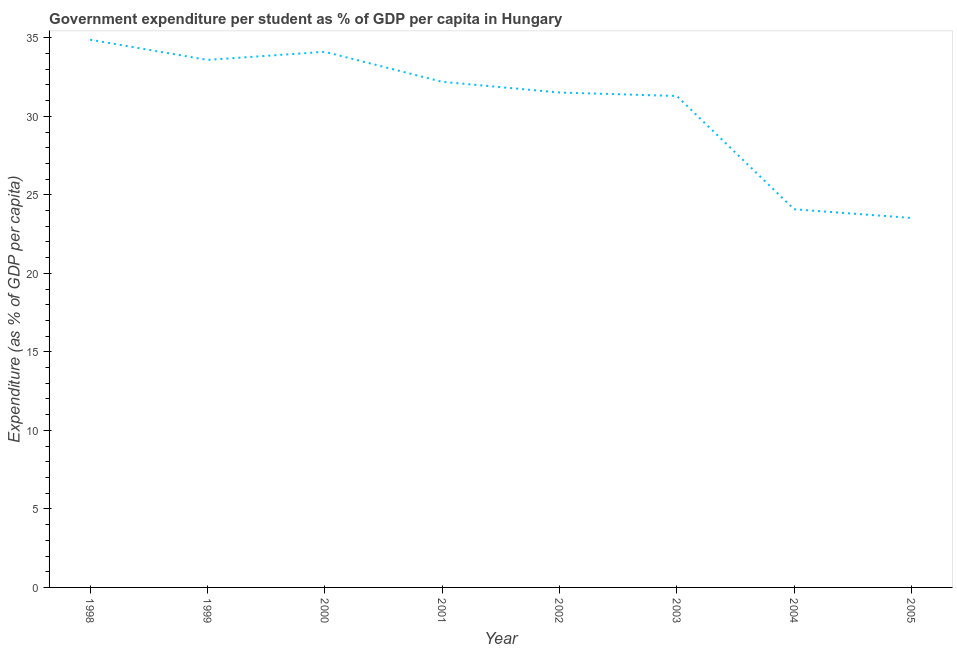What is the government expenditure per student in 1999?
Make the answer very short. 33.59. Across all years, what is the maximum government expenditure per student?
Give a very brief answer. 34.88. Across all years, what is the minimum government expenditure per student?
Ensure brevity in your answer.  23.53. In which year was the government expenditure per student minimum?
Provide a succinct answer. 2005. What is the sum of the government expenditure per student?
Your answer should be very brief. 245.18. What is the difference between the government expenditure per student in 2000 and 2001?
Give a very brief answer. 1.91. What is the average government expenditure per student per year?
Give a very brief answer. 30.65. What is the median government expenditure per student?
Make the answer very short. 31.86. Do a majority of the years between 2004 and 2002 (inclusive) have government expenditure per student greater than 8 %?
Your response must be concise. No. What is the ratio of the government expenditure per student in 1998 to that in 2001?
Your answer should be compact. 1.08. Is the government expenditure per student in 1998 less than that in 2002?
Make the answer very short. No. Is the difference between the government expenditure per student in 1998 and 2001 greater than the difference between any two years?
Provide a succinct answer. No. What is the difference between the highest and the second highest government expenditure per student?
Make the answer very short. 0.77. What is the difference between the highest and the lowest government expenditure per student?
Your answer should be compact. 11.35. In how many years, is the government expenditure per student greater than the average government expenditure per student taken over all years?
Your answer should be compact. 6. Are the values on the major ticks of Y-axis written in scientific E-notation?
Provide a succinct answer. No. What is the title of the graph?
Give a very brief answer. Government expenditure per student as % of GDP per capita in Hungary. What is the label or title of the X-axis?
Keep it short and to the point. Year. What is the label or title of the Y-axis?
Offer a terse response. Expenditure (as % of GDP per capita). What is the Expenditure (as % of GDP per capita) in 1998?
Give a very brief answer. 34.88. What is the Expenditure (as % of GDP per capita) in 1999?
Ensure brevity in your answer.  33.59. What is the Expenditure (as % of GDP per capita) in 2000?
Your answer should be compact. 34.11. What is the Expenditure (as % of GDP per capita) in 2001?
Offer a terse response. 32.2. What is the Expenditure (as % of GDP per capita) in 2002?
Your answer should be compact. 31.51. What is the Expenditure (as % of GDP per capita) in 2003?
Provide a succinct answer. 31.29. What is the Expenditure (as % of GDP per capita) in 2004?
Your answer should be compact. 24.08. What is the Expenditure (as % of GDP per capita) of 2005?
Make the answer very short. 23.53. What is the difference between the Expenditure (as % of GDP per capita) in 1998 and 1999?
Your answer should be very brief. 1.28. What is the difference between the Expenditure (as % of GDP per capita) in 1998 and 2000?
Provide a succinct answer. 0.77. What is the difference between the Expenditure (as % of GDP per capita) in 1998 and 2001?
Offer a terse response. 2.68. What is the difference between the Expenditure (as % of GDP per capita) in 1998 and 2002?
Keep it short and to the point. 3.36. What is the difference between the Expenditure (as % of GDP per capita) in 1998 and 2003?
Offer a very short reply. 3.58. What is the difference between the Expenditure (as % of GDP per capita) in 1998 and 2004?
Offer a very short reply. 10.79. What is the difference between the Expenditure (as % of GDP per capita) in 1998 and 2005?
Offer a very short reply. 11.35. What is the difference between the Expenditure (as % of GDP per capita) in 1999 and 2000?
Provide a succinct answer. -0.52. What is the difference between the Expenditure (as % of GDP per capita) in 1999 and 2001?
Provide a short and direct response. 1.4. What is the difference between the Expenditure (as % of GDP per capita) in 1999 and 2002?
Offer a terse response. 2.08. What is the difference between the Expenditure (as % of GDP per capita) in 1999 and 2003?
Make the answer very short. 2.3. What is the difference between the Expenditure (as % of GDP per capita) in 1999 and 2004?
Your response must be concise. 9.51. What is the difference between the Expenditure (as % of GDP per capita) in 1999 and 2005?
Your answer should be very brief. 10.07. What is the difference between the Expenditure (as % of GDP per capita) in 2000 and 2001?
Give a very brief answer. 1.91. What is the difference between the Expenditure (as % of GDP per capita) in 2000 and 2002?
Keep it short and to the point. 2.59. What is the difference between the Expenditure (as % of GDP per capita) in 2000 and 2003?
Keep it short and to the point. 2.81. What is the difference between the Expenditure (as % of GDP per capita) in 2000 and 2004?
Ensure brevity in your answer.  10.03. What is the difference between the Expenditure (as % of GDP per capita) in 2000 and 2005?
Your answer should be very brief. 10.58. What is the difference between the Expenditure (as % of GDP per capita) in 2001 and 2002?
Keep it short and to the point. 0.68. What is the difference between the Expenditure (as % of GDP per capita) in 2001 and 2003?
Make the answer very short. 0.9. What is the difference between the Expenditure (as % of GDP per capita) in 2001 and 2004?
Keep it short and to the point. 8.12. What is the difference between the Expenditure (as % of GDP per capita) in 2001 and 2005?
Give a very brief answer. 8.67. What is the difference between the Expenditure (as % of GDP per capita) in 2002 and 2003?
Make the answer very short. 0.22. What is the difference between the Expenditure (as % of GDP per capita) in 2002 and 2004?
Make the answer very short. 7.43. What is the difference between the Expenditure (as % of GDP per capita) in 2002 and 2005?
Offer a terse response. 7.99. What is the difference between the Expenditure (as % of GDP per capita) in 2003 and 2004?
Provide a short and direct response. 7.21. What is the difference between the Expenditure (as % of GDP per capita) in 2003 and 2005?
Provide a short and direct response. 7.77. What is the difference between the Expenditure (as % of GDP per capita) in 2004 and 2005?
Your answer should be very brief. 0.56. What is the ratio of the Expenditure (as % of GDP per capita) in 1998 to that in 1999?
Your response must be concise. 1.04. What is the ratio of the Expenditure (as % of GDP per capita) in 1998 to that in 2000?
Keep it short and to the point. 1.02. What is the ratio of the Expenditure (as % of GDP per capita) in 1998 to that in 2001?
Give a very brief answer. 1.08. What is the ratio of the Expenditure (as % of GDP per capita) in 1998 to that in 2002?
Provide a short and direct response. 1.11. What is the ratio of the Expenditure (as % of GDP per capita) in 1998 to that in 2003?
Offer a very short reply. 1.11. What is the ratio of the Expenditure (as % of GDP per capita) in 1998 to that in 2004?
Offer a very short reply. 1.45. What is the ratio of the Expenditure (as % of GDP per capita) in 1998 to that in 2005?
Ensure brevity in your answer.  1.48. What is the ratio of the Expenditure (as % of GDP per capita) in 1999 to that in 2001?
Ensure brevity in your answer.  1.04. What is the ratio of the Expenditure (as % of GDP per capita) in 1999 to that in 2002?
Offer a terse response. 1.07. What is the ratio of the Expenditure (as % of GDP per capita) in 1999 to that in 2003?
Your answer should be compact. 1.07. What is the ratio of the Expenditure (as % of GDP per capita) in 1999 to that in 2004?
Your answer should be compact. 1.4. What is the ratio of the Expenditure (as % of GDP per capita) in 1999 to that in 2005?
Your response must be concise. 1.43. What is the ratio of the Expenditure (as % of GDP per capita) in 2000 to that in 2001?
Ensure brevity in your answer.  1.06. What is the ratio of the Expenditure (as % of GDP per capita) in 2000 to that in 2002?
Provide a succinct answer. 1.08. What is the ratio of the Expenditure (as % of GDP per capita) in 2000 to that in 2003?
Make the answer very short. 1.09. What is the ratio of the Expenditure (as % of GDP per capita) in 2000 to that in 2004?
Keep it short and to the point. 1.42. What is the ratio of the Expenditure (as % of GDP per capita) in 2000 to that in 2005?
Offer a very short reply. 1.45. What is the ratio of the Expenditure (as % of GDP per capita) in 2001 to that in 2002?
Your answer should be very brief. 1.02. What is the ratio of the Expenditure (as % of GDP per capita) in 2001 to that in 2004?
Give a very brief answer. 1.34. What is the ratio of the Expenditure (as % of GDP per capita) in 2001 to that in 2005?
Your response must be concise. 1.37. What is the ratio of the Expenditure (as % of GDP per capita) in 2002 to that in 2003?
Keep it short and to the point. 1.01. What is the ratio of the Expenditure (as % of GDP per capita) in 2002 to that in 2004?
Give a very brief answer. 1.31. What is the ratio of the Expenditure (as % of GDP per capita) in 2002 to that in 2005?
Offer a terse response. 1.34. What is the ratio of the Expenditure (as % of GDP per capita) in 2003 to that in 2004?
Offer a very short reply. 1.3. What is the ratio of the Expenditure (as % of GDP per capita) in 2003 to that in 2005?
Offer a terse response. 1.33. 